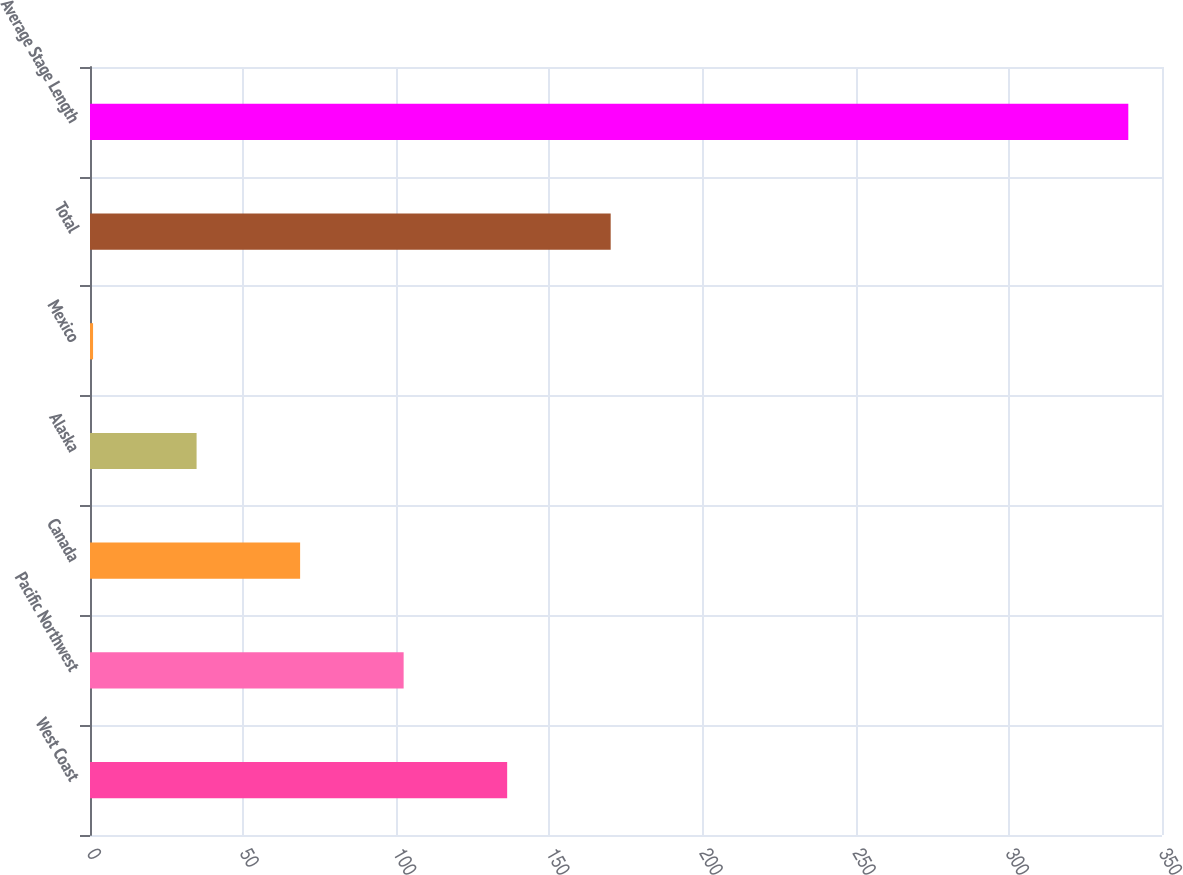Convert chart to OTSL. <chart><loc_0><loc_0><loc_500><loc_500><bar_chart><fcel>West Coast<fcel>Pacific Northwest<fcel>Canada<fcel>Alaska<fcel>Mexico<fcel>Total<fcel>Average Stage Length<nl><fcel>136.2<fcel>102.4<fcel>68.6<fcel>34.8<fcel>1<fcel>170<fcel>339<nl></chart> 